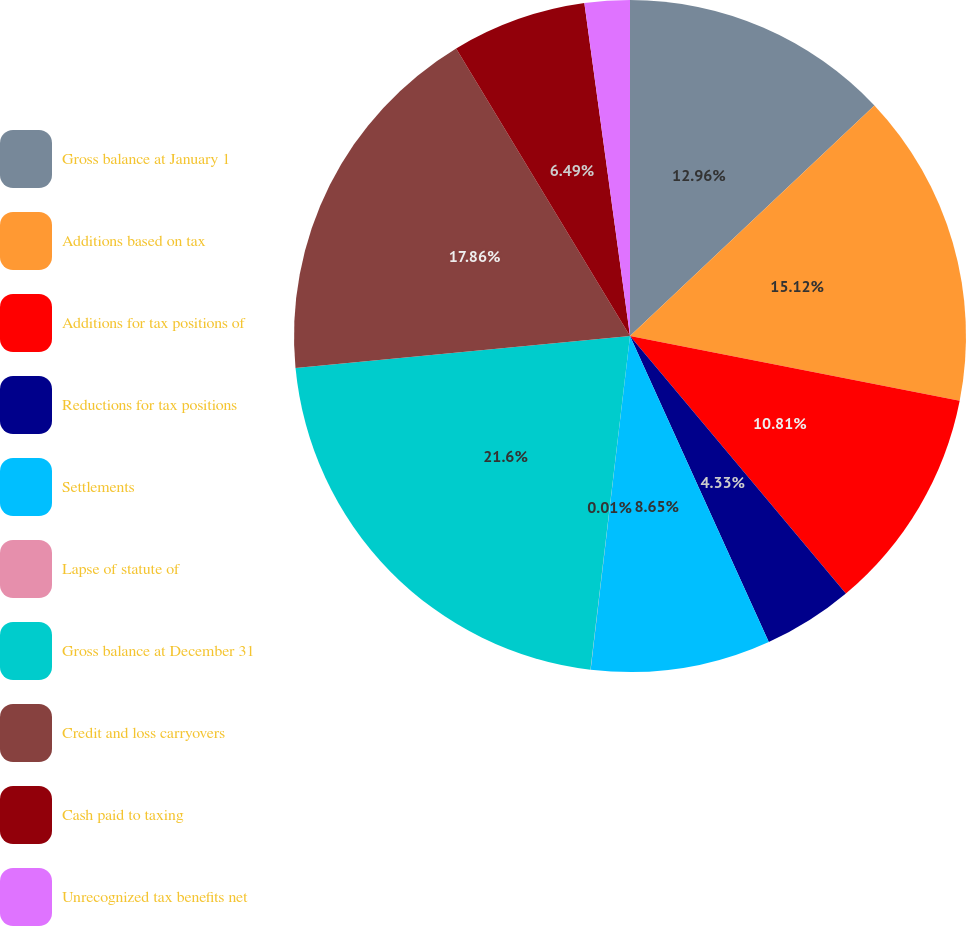Convert chart to OTSL. <chart><loc_0><loc_0><loc_500><loc_500><pie_chart><fcel>Gross balance at January 1<fcel>Additions based on tax<fcel>Additions for tax positions of<fcel>Reductions for tax positions<fcel>Settlements<fcel>Lapse of statute of<fcel>Gross balance at December 31<fcel>Credit and loss carryovers<fcel>Cash paid to taxing<fcel>Unrecognized tax benefits net<nl><fcel>12.97%<fcel>15.13%<fcel>10.81%<fcel>4.33%<fcel>8.65%<fcel>0.01%<fcel>21.61%<fcel>17.87%<fcel>6.49%<fcel>2.17%<nl></chart> 